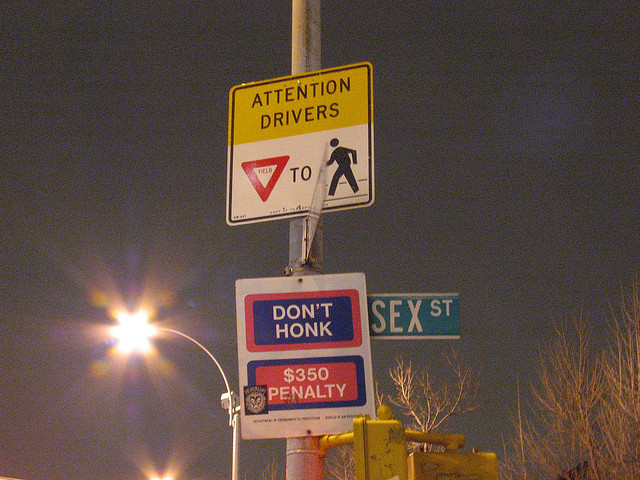Read all the text in this image. ATTENTION DRIVERS TO DON'T HONK PENALTY $350 ST SEX 